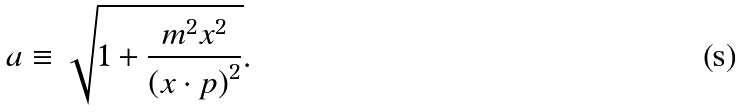Convert formula to latex. <formula><loc_0><loc_0><loc_500><loc_500>a \equiv \sqrt { 1 + \frac { m ^ { 2 } x ^ { 2 } } { \left ( x \cdot p \right ) ^ { 2 } } } .</formula> 